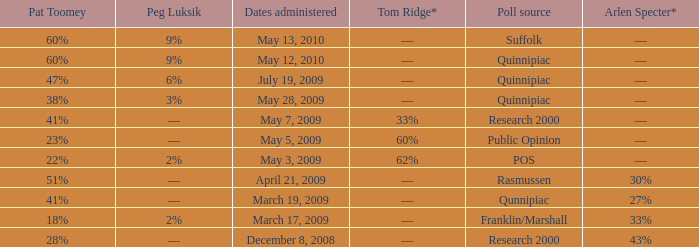Which Dates administered has an Arlen Specter* of ––, and a Peg Luksik of 9%? May 13, 2010, May 12, 2010. 